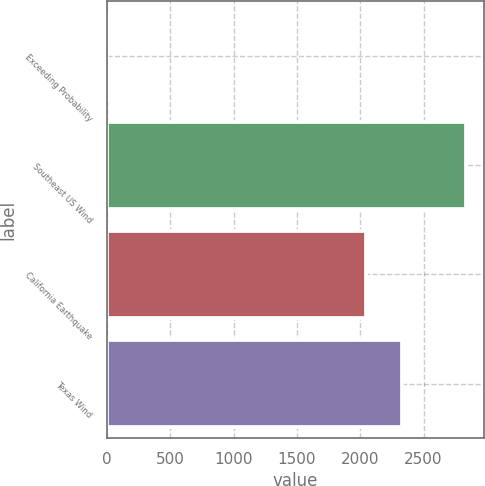<chart> <loc_0><loc_0><loc_500><loc_500><bar_chart><fcel>Exceeding Probability<fcel>Southeast US Wind<fcel>California Earthquake<fcel>Texas Wind<nl><fcel>0.1<fcel>2838<fcel>2042<fcel>2325.79<nl></chart> 